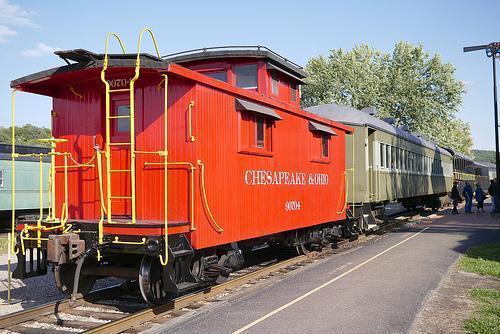How many people are shown?
Give a very brief answer. 4. 